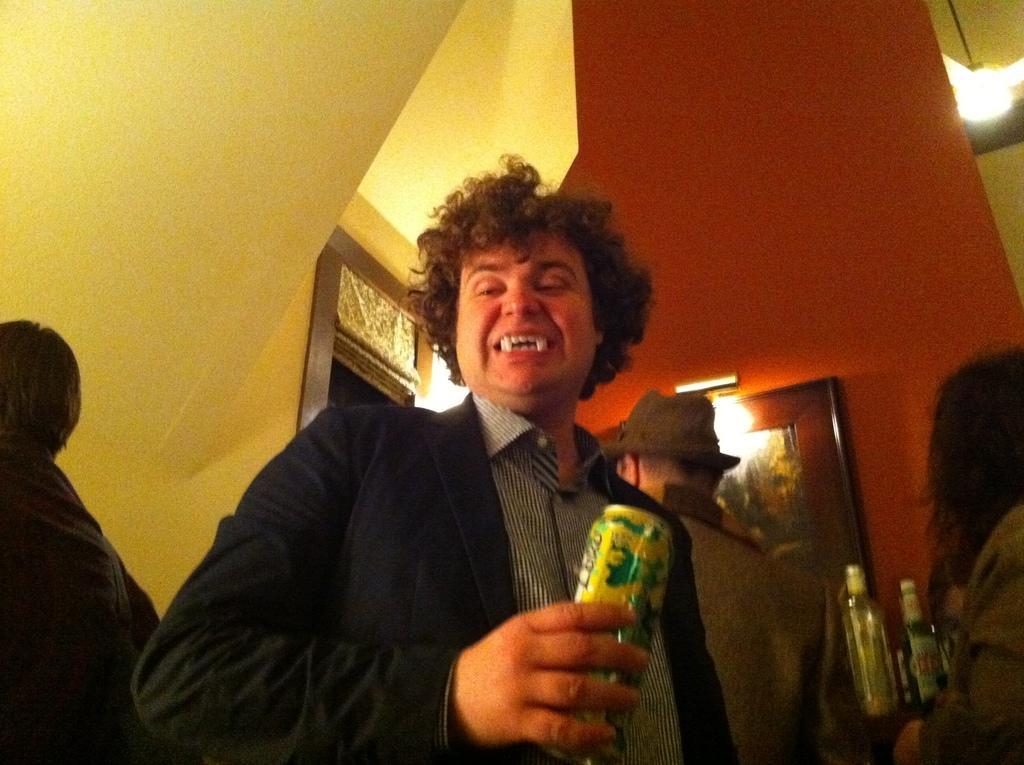Can you describe this image briefly? In this image there is a man standing and holding a tin in his hand ,at the back ground there are group of persons standing , group of wine bottles in a rack, frame , door, light. 